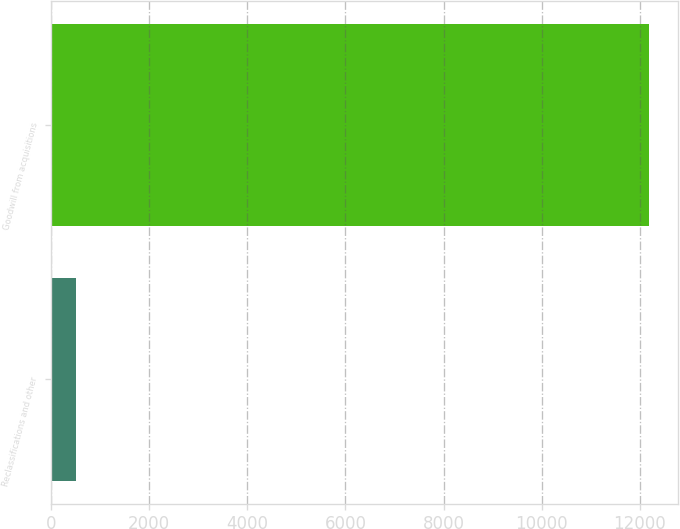<chart> <loc_0><loc_0><loc_500><loc_500><bar_chart><fcel>Reclassifications and other<fcel>Goodwill from acquisitions<nl><fcel>516<fcel>12181<nl></chart> 